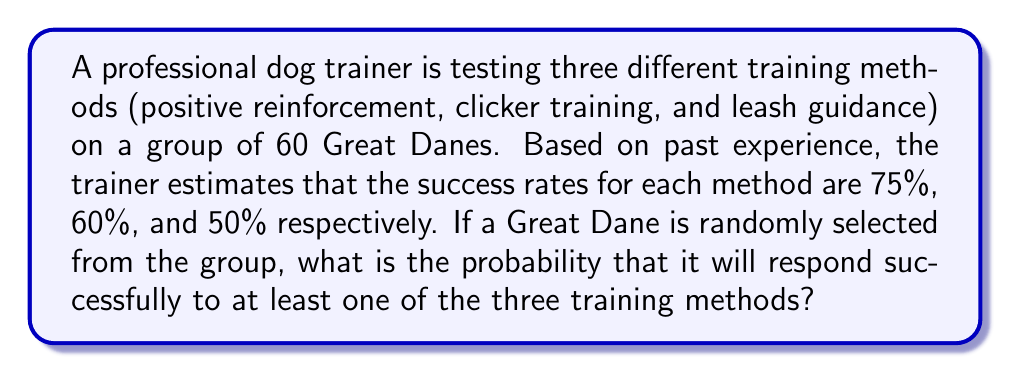Solve this math problem. Let's approach this step-by-step:

1) First, let's define our events:
   A: Success with positive reinforcement (P(A) = 0.75)
   B: Success with clicker training (P(B) = 0.60)
   C: Success with leash guidance (P(C) = 0.50)

2) We want to find the probability of at least one success, which is easier to calculate by subtracting the probability of no success from 1:

   P(at least one success) = 1 - P(no success)

3) The probability of no success is the probability that the dog fails all three methods:

   P(no success) = P(not A and not B and not C)

4) Assuming the events are independent, we can multiply the probabilities:

   P(no success) = (1 - P(A)) * (1 - P(B)) * (1 - P(C))

5) Let's calculate:

   P(no success) = (1 - 0.75) * (1 - 0.60) * (1 - 0.50)
                 = 0.25 * 0.40 * 0.50
                 = 0.05

6) Now we can find our answer:

   P(at least one success) = 1 - P(no success)
                           = 1 - 0.05
                           = 0.95

Therefore, the probability that a randomly selected Great Dane will respond successfully to at least one of the three training methods is 0.95 or 95%.
Answer: 0.95 